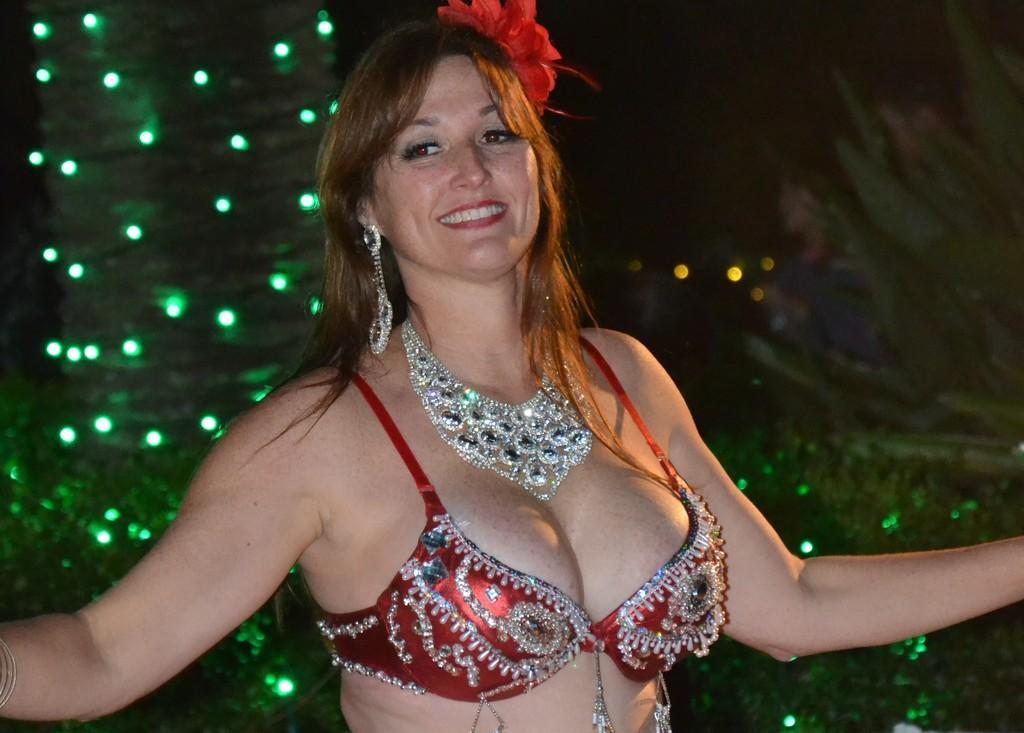Could you give a brief overview of what you see in this image? In the middle of the image a woman is standing and smiling. Behind her we can see some trees and lights. 